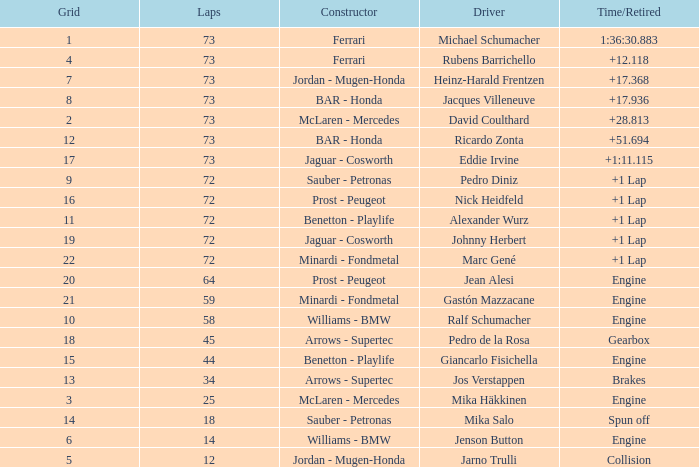How many laps did Jos Verstappen do on Grid 2? 34.0. 